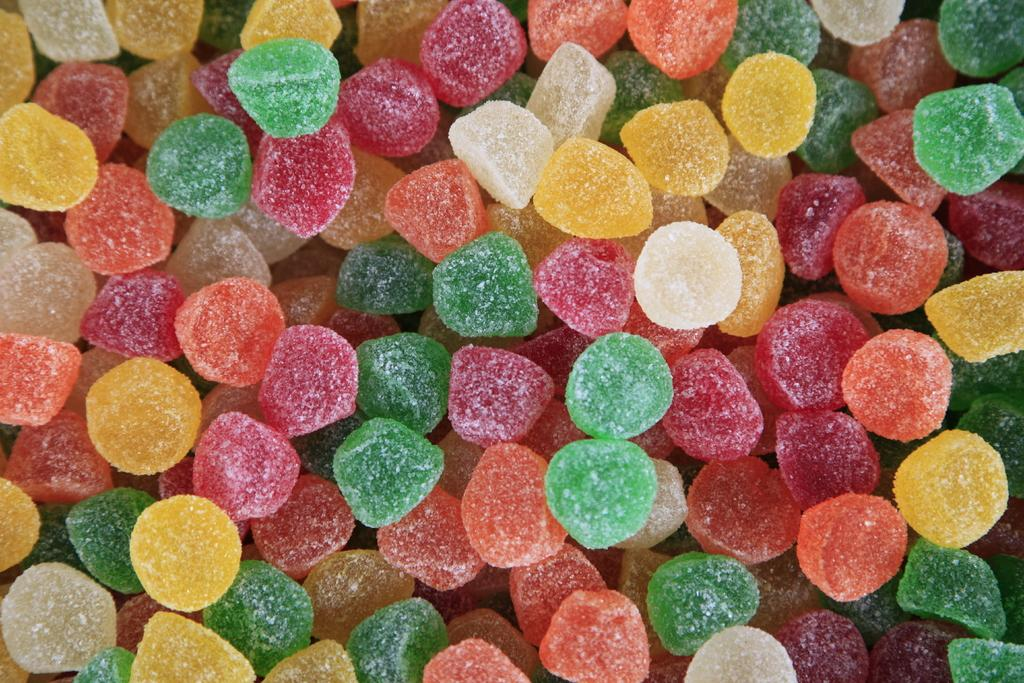What type of sweets are in the image? There are sugar candies in the image. What distinguishing feature do the sugar candies have? The sugar candies are of different colors. Where are the sugar candies located? The sugar candies are in a place. What type of chalk is being used to draw on the hour in the image? There is no chalk or drawing on an hour present in the image. What type of religious building is depicted in the image? There is no religious building or any reference to a church in the image. 